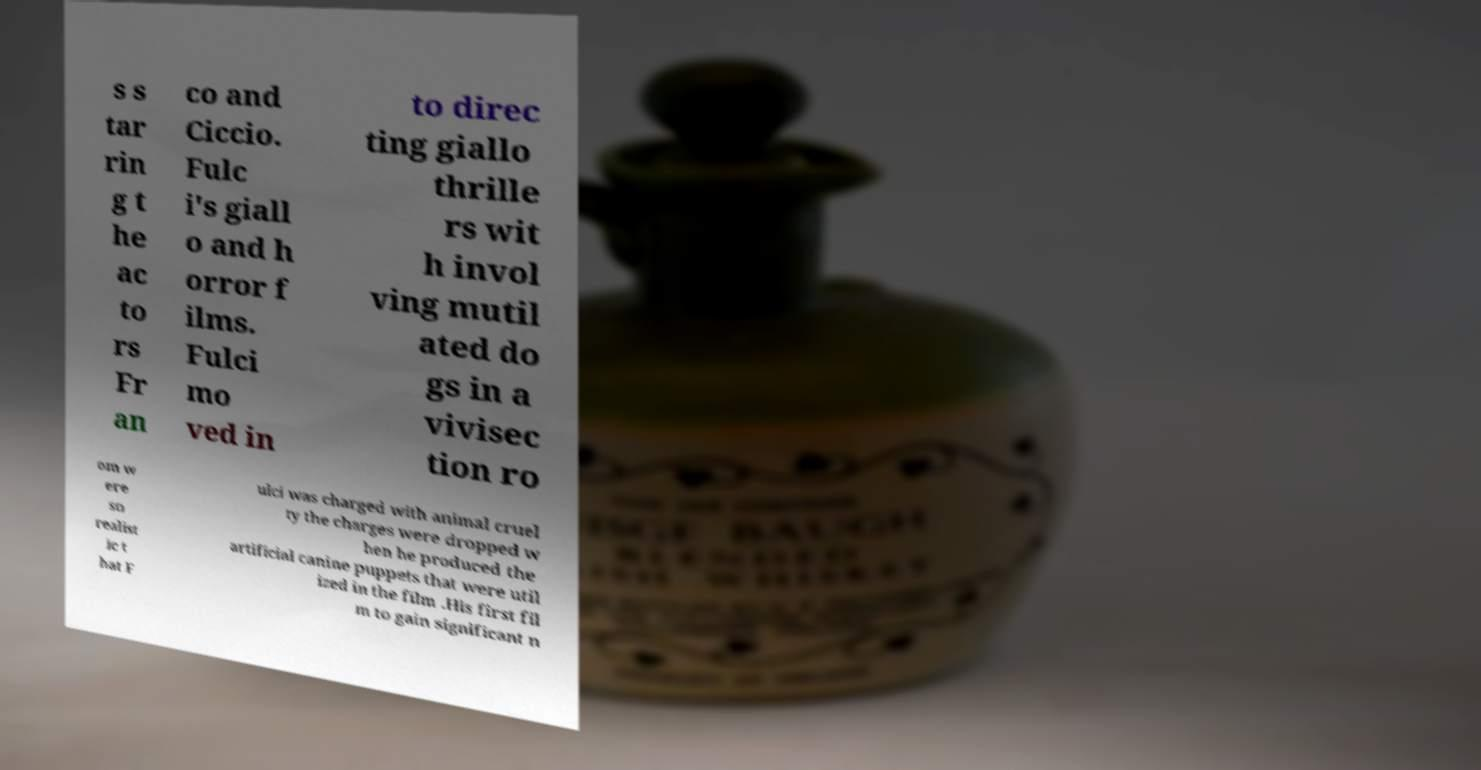Could you assist in decoding the text presented in this image and type it out clearly? s s tar rin g t he ac to rs Fr an co and Ciccio. Fulc i's giall o and h orror f ilms. Fulci mo ved in to direc ting giallo thrille rs wit h invol ving mutil ated do gs in a vivisec tion ro om w ere so realist ic t hat F ulci was charged with animal cruel ty the charges were dropped w hen he produced the artificial canine puppets that were util ized in the film .His first fil m to gain significant n 